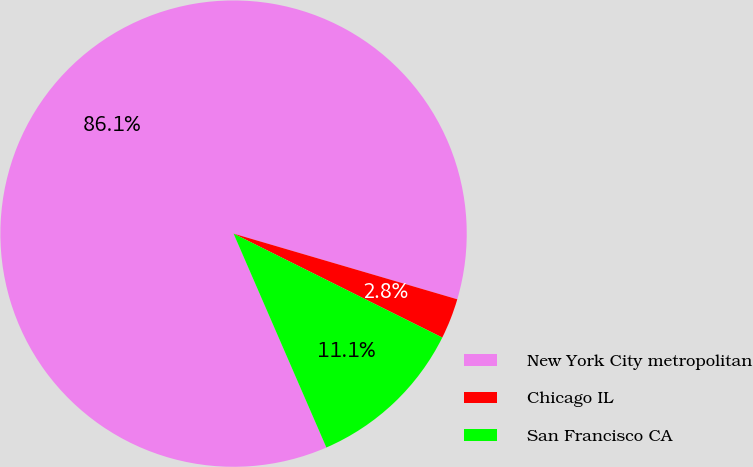Convert chart to OTSL. <chart><loc_0><loc_0><loc_500><loc_500><pie_chart><fcel>New York City metropolitan<fcel>Chicago IL<fcel>San Francisco CA<nl><fcel>86.06%<fcel>2.81%<fcel>11.13%<nl></chart> 